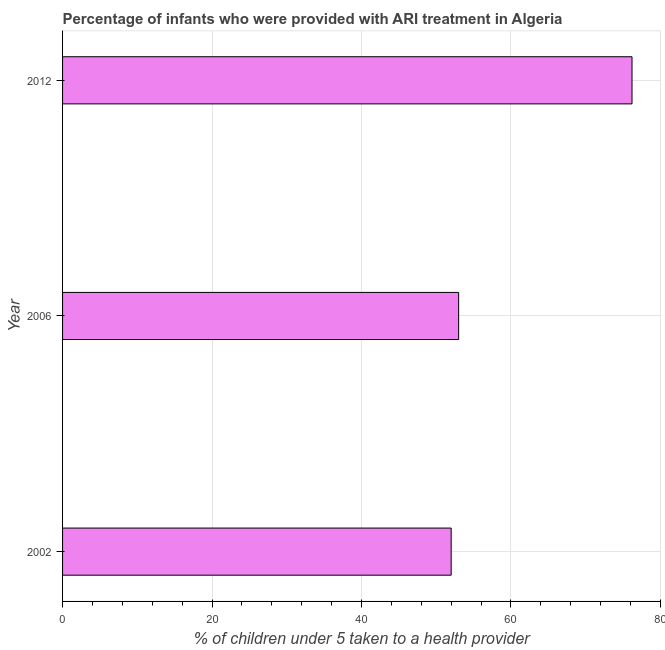Does the graph contain any zero values?
Provide a succinct answer. No. Does the graph contain grids?
Keep it short and to the point. Yes. What is the title of the graph?
Make the answer very short. Percentage of infants who were provided with ARI treatment in Algeria. What is the label or title of the X-axis?
Give a very brief answer. % of children under 5 taken to a health provider. What is the percentage of children who were provided with ari treatment in 2002?
Provide a short and direct response. 52. Across all years, what is the maximum percentage of children who were provided with ari treatment?
Ensure brevity in your answer.  76.2. In which year was the percentage of children who were provided with ari treatment maximum?
Keep it short and to the point. 2012. What is the sum of the percentage of children who were provided with ari treatment?
Offer a very short reply. 181.2. What is the difference between the percentage of children who were provided with ari treatment in 2002 and 2006?
Your answer should be very brief. -1. What is the average percentage of children who were provided with ari treatment per year?
Your response must be concise. 60.4. What is the median percentage of children who were provided with ari treatment?
Provide a succinct answer. 53. Do a majority of the years between 2002 and 2006 (inclusive) have percentage of children who were provided with ari treatment greater than 24 %?
Make the answer very short. Yes. What is the ratio of the percentage of children who were provided with ari treatment in 2002 to that in 2012?
Your answer should be very brief. 0.68. What is the difference between the highest and the second highest percentage of children who were provided with ari treatment?
Provide a short and direct response. 23.2. Is the sum of the percentage of children who were provided with ari treatment in 2002 and 2012 greater than the maximum percentage of children who were provided with ari treatment across all years?
Offer a terse response. Yes. What is the difference between the highest and the lowest percentage of children who were provided with ari treatment?
Offer a terse response. 24.2. How many bars are there?
Offer a terse response. 3. How many years are there in the graph?
Offer a terse response. 3. What is the % of children under 5 taken to a health provider of 2002?
Provide a short and direct response. 52. What is the % of children under 5 taken to a health provider of 2012?
Your answer should be very brief. 76.2. What is the difference between the % of children under 5 taken to a health provider in 2002 and 2006?
Keep it short and to the point. -1. What is the difference between the % of children under 5 taken to a health provider in 2002 and 2012?
Provide a short and direct response. -24.2. What is the difference between the % of children under 5 taken to a health provider in 2006 and 2012?
Your answer should be compact. -23.2. What is the ratio of the % of children under 5 taken to a health provider in 2002 to that in 2006?
Provide a short and direct response. 0.98. What is the ratio of the % of children under 5 taken to a health provider in 2002 to that in 2012?
Provide a short and direct response. 0.68. What is the ratio of the % of children under 5 taken to a health provider in 2006 to that in 2012?
Make the answer very short. 0.7. 